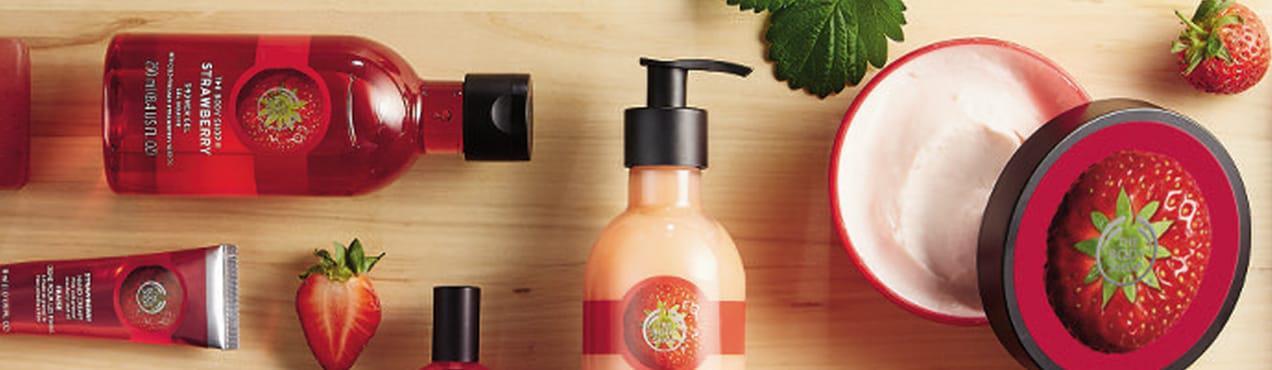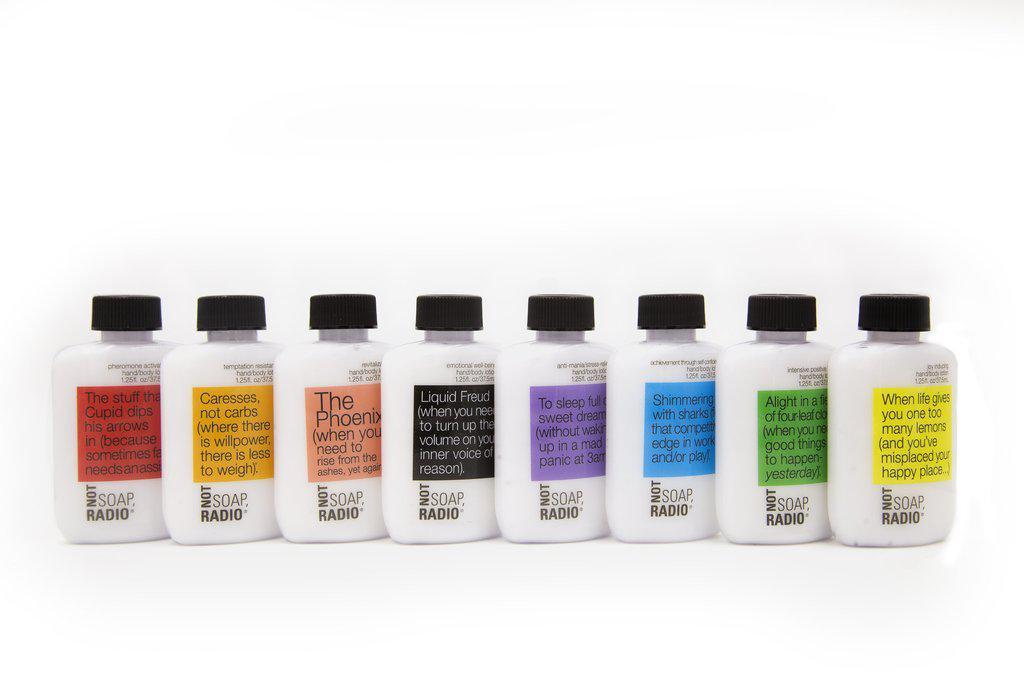The first image is the image on the left, the second image is the image on the right. Considering the images on both sides, is "Some items are laying flat." valid? Answer yes or no. Yes. 